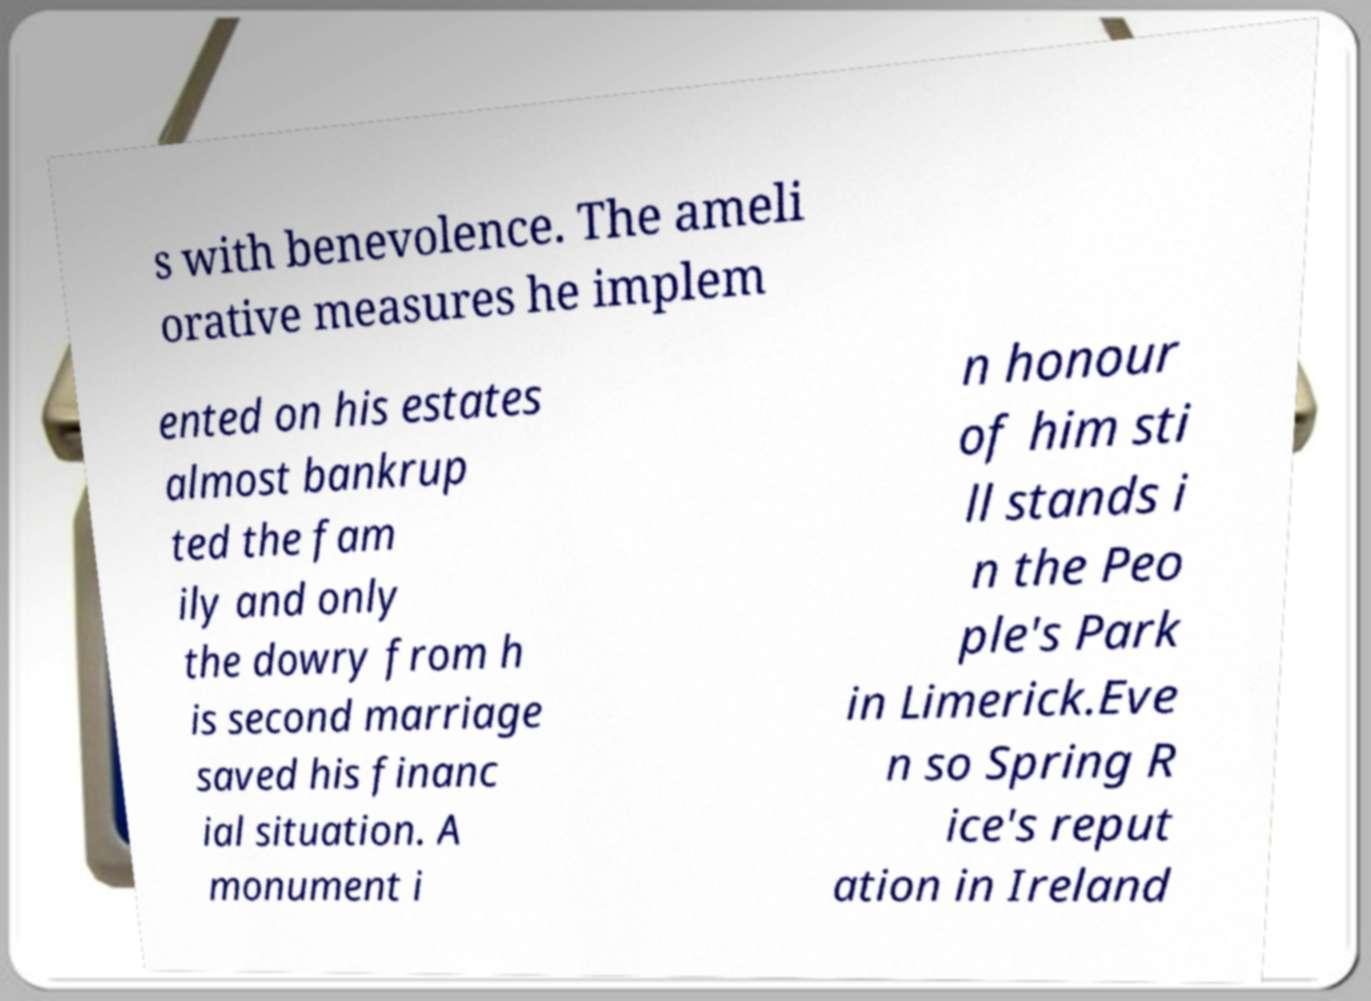For documentation purposes, I need the text within this image transcribed. Could you provide that? s with benevolence. The ameli orative measures he implem ented on his estates almost bankrup ted the fam ily and only the dowry from h is second marriage saved his financ ial situation. A monument i n honour of him sti ll stands i n the Peo ple's Park in Limerick.Eve n so Spring R ice's reput ation in Ireland 